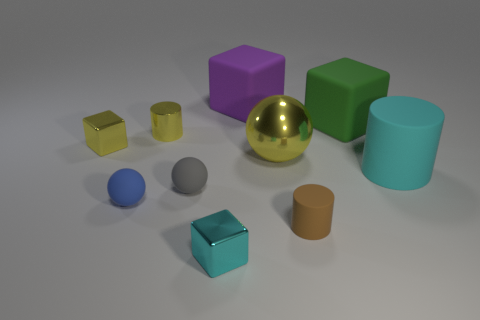Subtract 1 blocks. How many blocks are left? 3 Subtract all spheres. How many objects are left? 7 Add 4 large cyan things. How many large cyan things are left? 5 Add 2 small balls. How many small balls exist? 4 Subtract 0 gray cubes. How many objects are left? 10 Subtract all tiny gray rubber spheres. Subtract all gray shiny cubes. How many objects are left? 9 